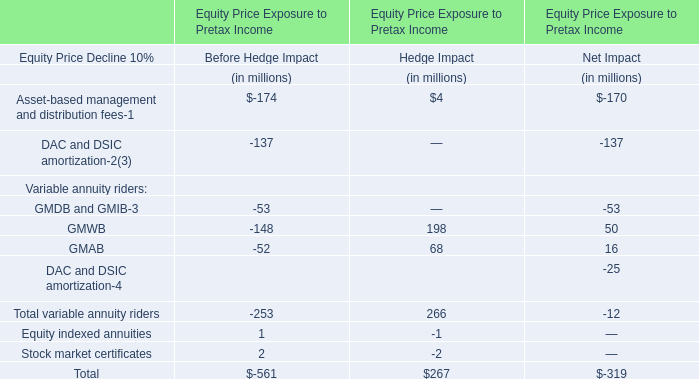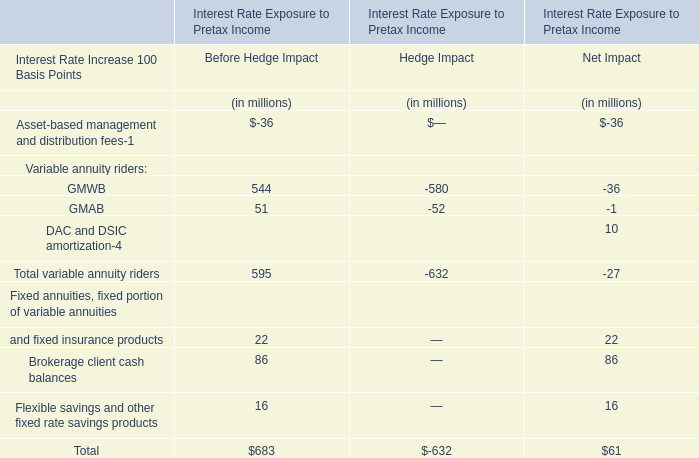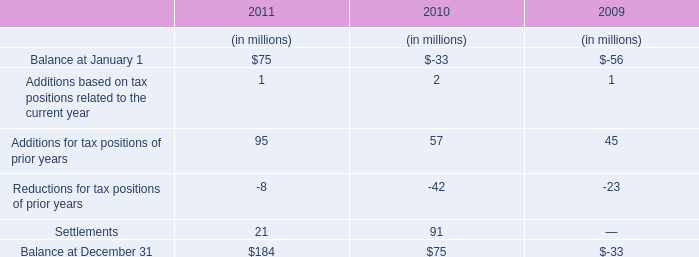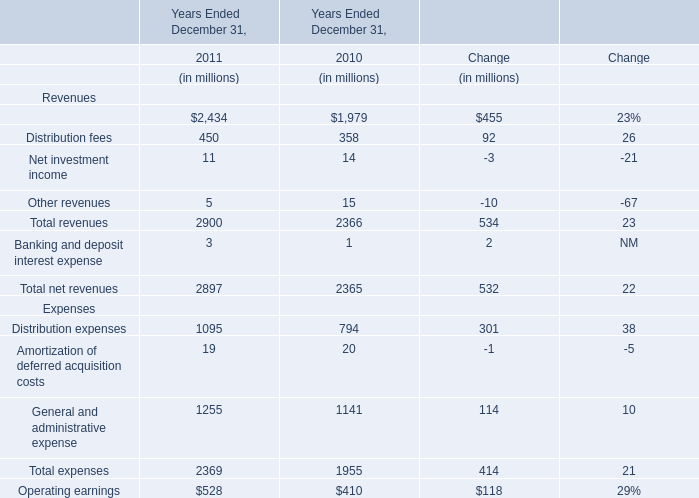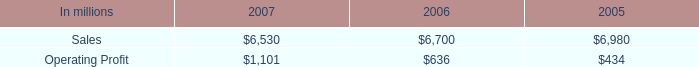what percent of printing papers sales in 2006 was from north american printing papers net sales? 
Computations: ((4.4 * 1000) / 6700)
Answer: 0.65672. 